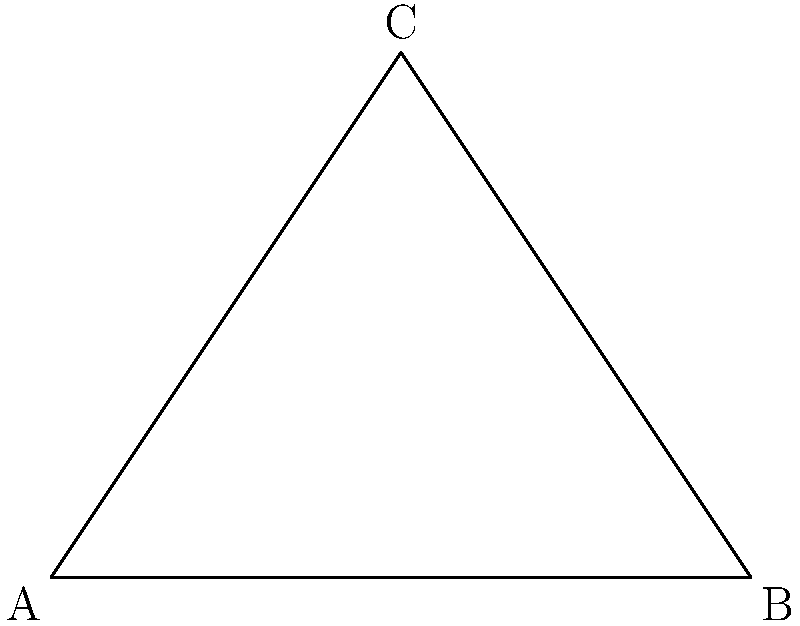Parinaaz's mother has prepared delicious samosas for the neighborhood gathering. The triangular shape of the samosa reminds you of your geometry lessons. If one angle of this samosa is a right angle (90°) and another angle is 60°, what is the measure of the third angle? Let's approach this step-by-step:

1) First, recall that the sum of angles in any triangle is always 180°.

2) We are given two angles of the triangle:
   - One angle is a right angle, which is 90°
   - Another angle is 60°

3) Let's call the third angle $x°$

4) Now, we can set up an equation based on the fact that the sum of angles in a triangle is 180°:

   $90° + 60° + x° = 180°$

5) Simplify the left side of the equation:

   $150° + x° = 180°$

6) Subtract 150° from both sides:

   $x° = 180° - 150°$

7) Simplify:

   $x° = 30°$

Therefore, the measure of the third angle is 30°.
Answer: 30° 